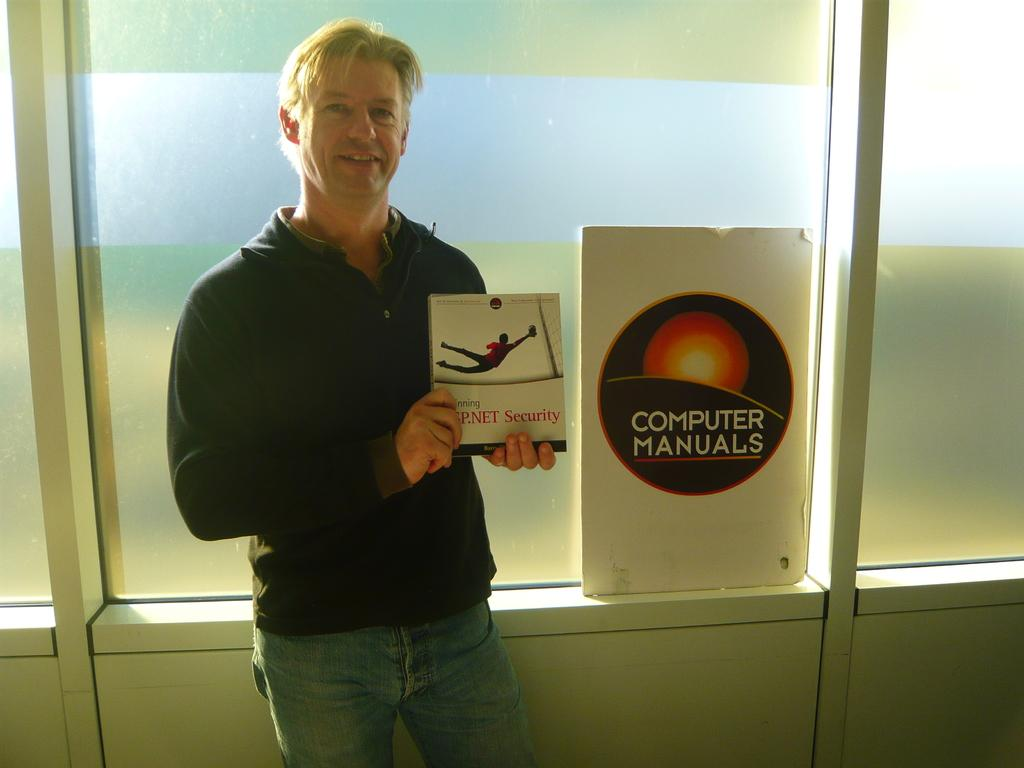Provide a one-sentence caption for the provided image. a man holding a book next to a sign for computer manuals. 